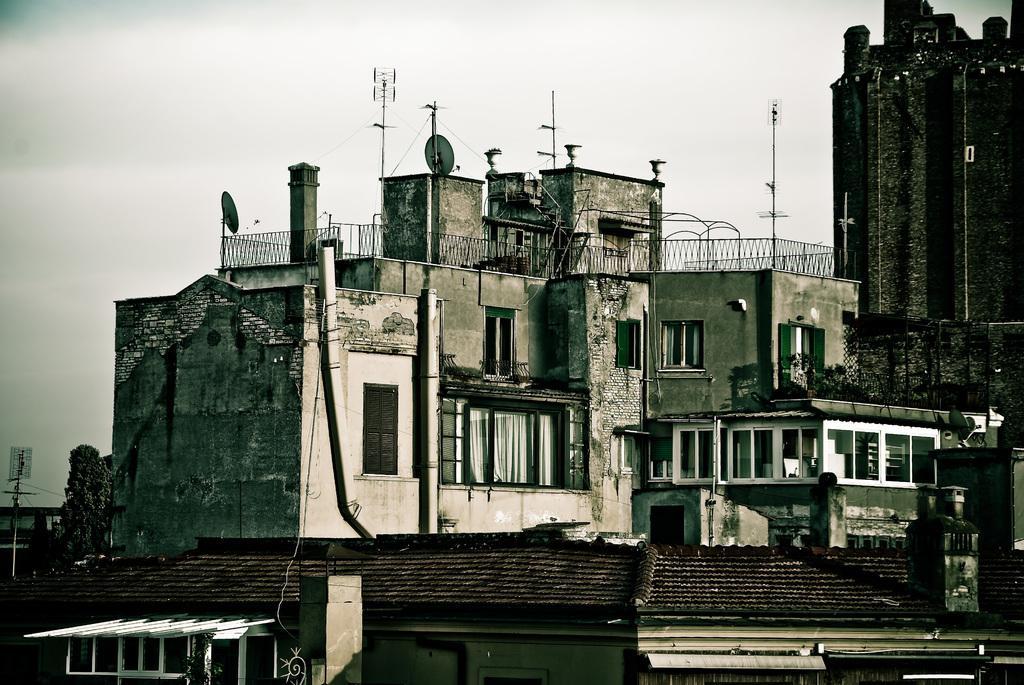Describe this image in one or two sentences. In this image I can see few buildings, few glass windows. Background I can see few poles and I can also see the railing and the sky is in white color. 